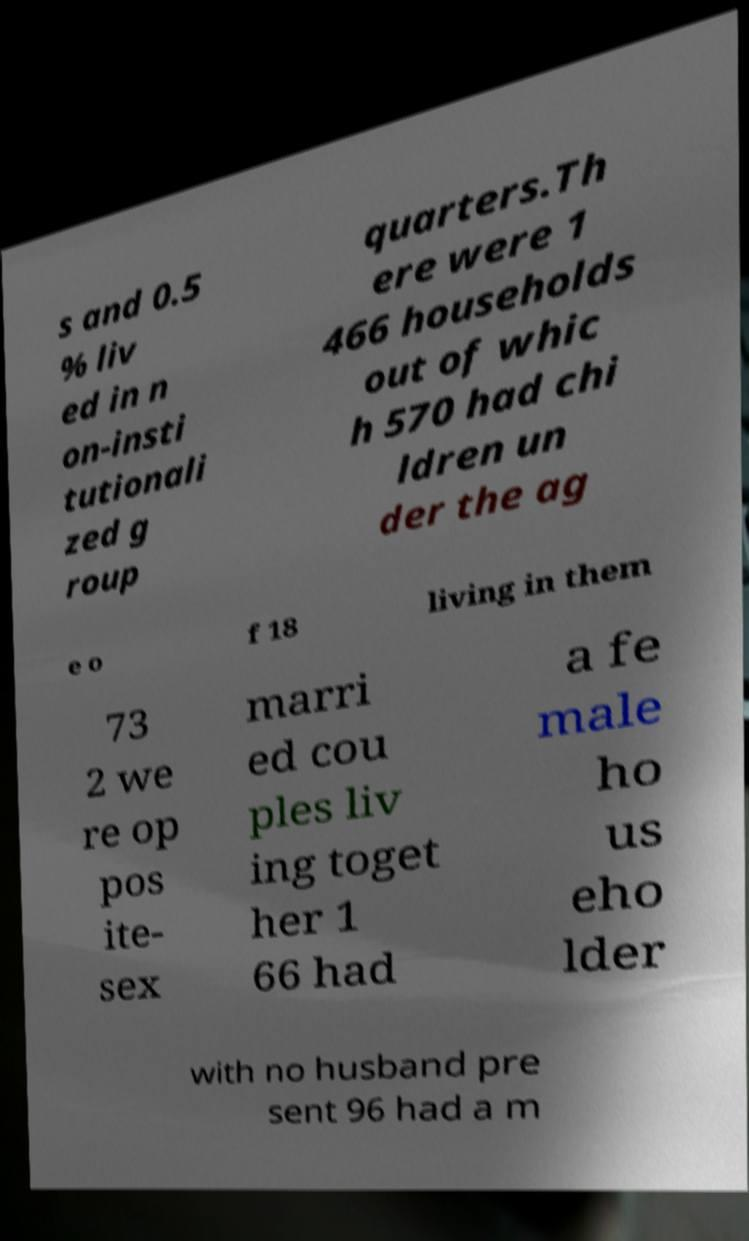Can you accurately transcribe the text from the provided image for me? s and 0.5 % liv ed in n on-insti tutionali zed g roup quarters.Th ere were 1 466 households out of whic h 570 had chi ldren un der the ag e o f 18 living in them 73 2 we re op pos ite- sex marri ed cou ples liv ing toget her 1 66 had a fe male ho us eho lder with no husband pre sent 96 had a m 